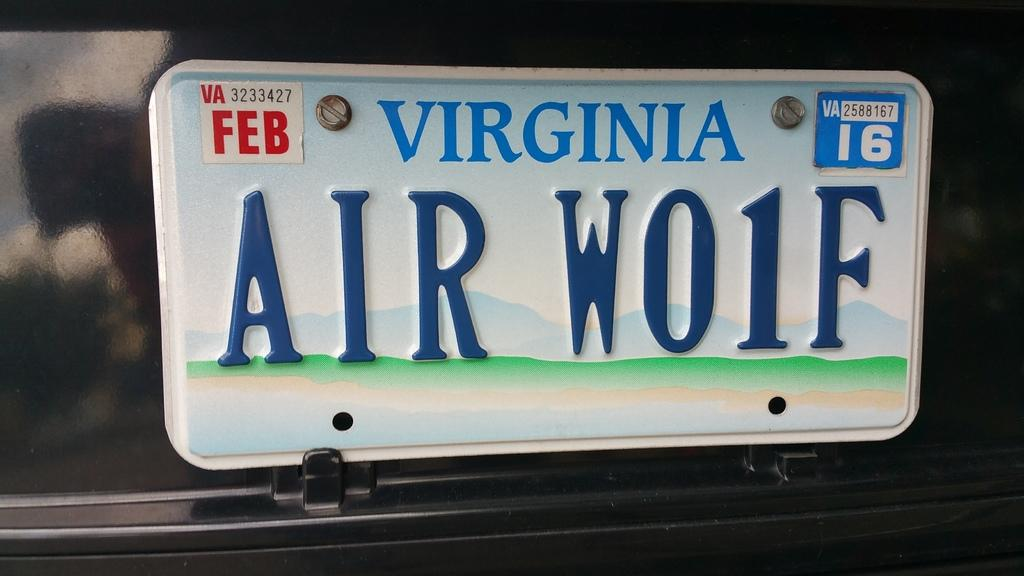Provide a one-sentence caption for the provided image. A Virginia licence plate with the words Air Wo1F. 